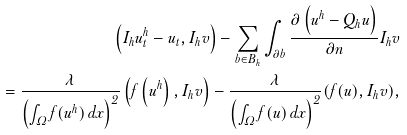<formula> <loc_0><loc_0><loc_500><loc_500>\left ( I _ { h } u _ { t } ^ { h } - u _ { t } , I _ { h } v \right ) - \sum _ { b \in B _ { h } } \int _ { \partial b } \frac { \partial \left ( u ^ { h } - Q _ { h } u \right ) } { \partial n } I _ { h } v \\ = \frac { \lambda } { \left ( \int _ { \Omega } f ( u ^ { h } ) \, d x \right ) ^ { 2 } } \left ( f \left ( u ^ { h } \right ) , I _ { h } v \right ) - \frac { \lambda } { \left ( \int _ { \Omega } f ( u ) \, d x \right ) ^ { 2 } } ( f ( u ) , I _ { h } v ) ,</formula> 